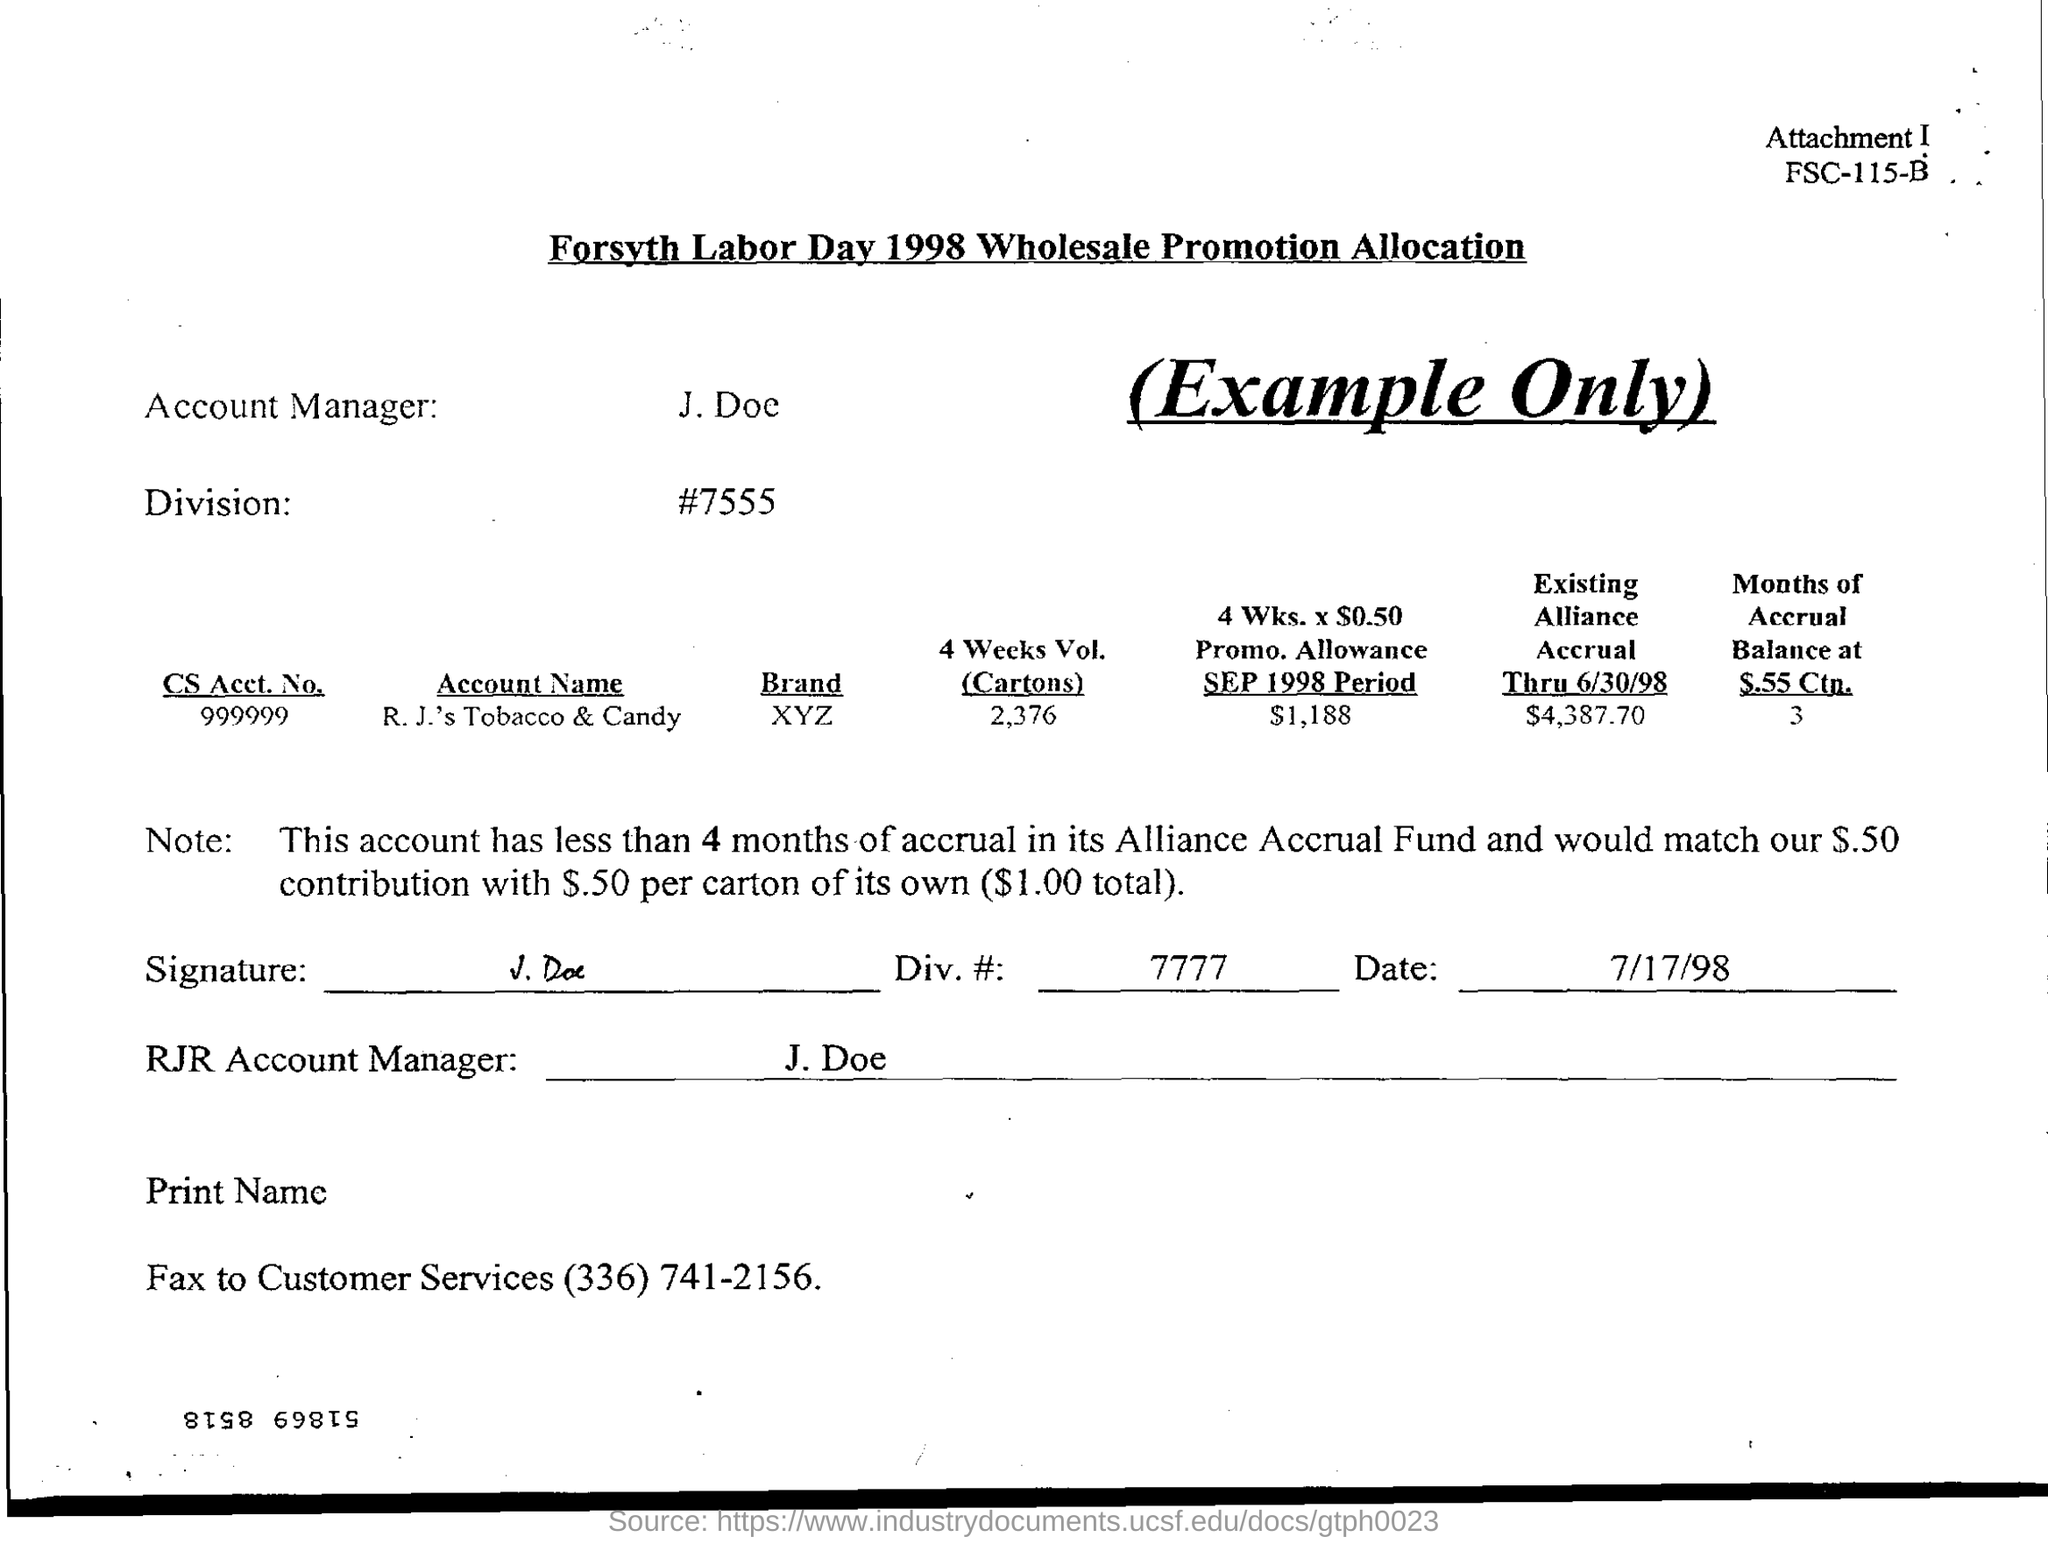Mention a couple of crucial points in this snapshot. The account manager is John Doe. The volume of 4 weeks' worth of cartons is 2,376. 